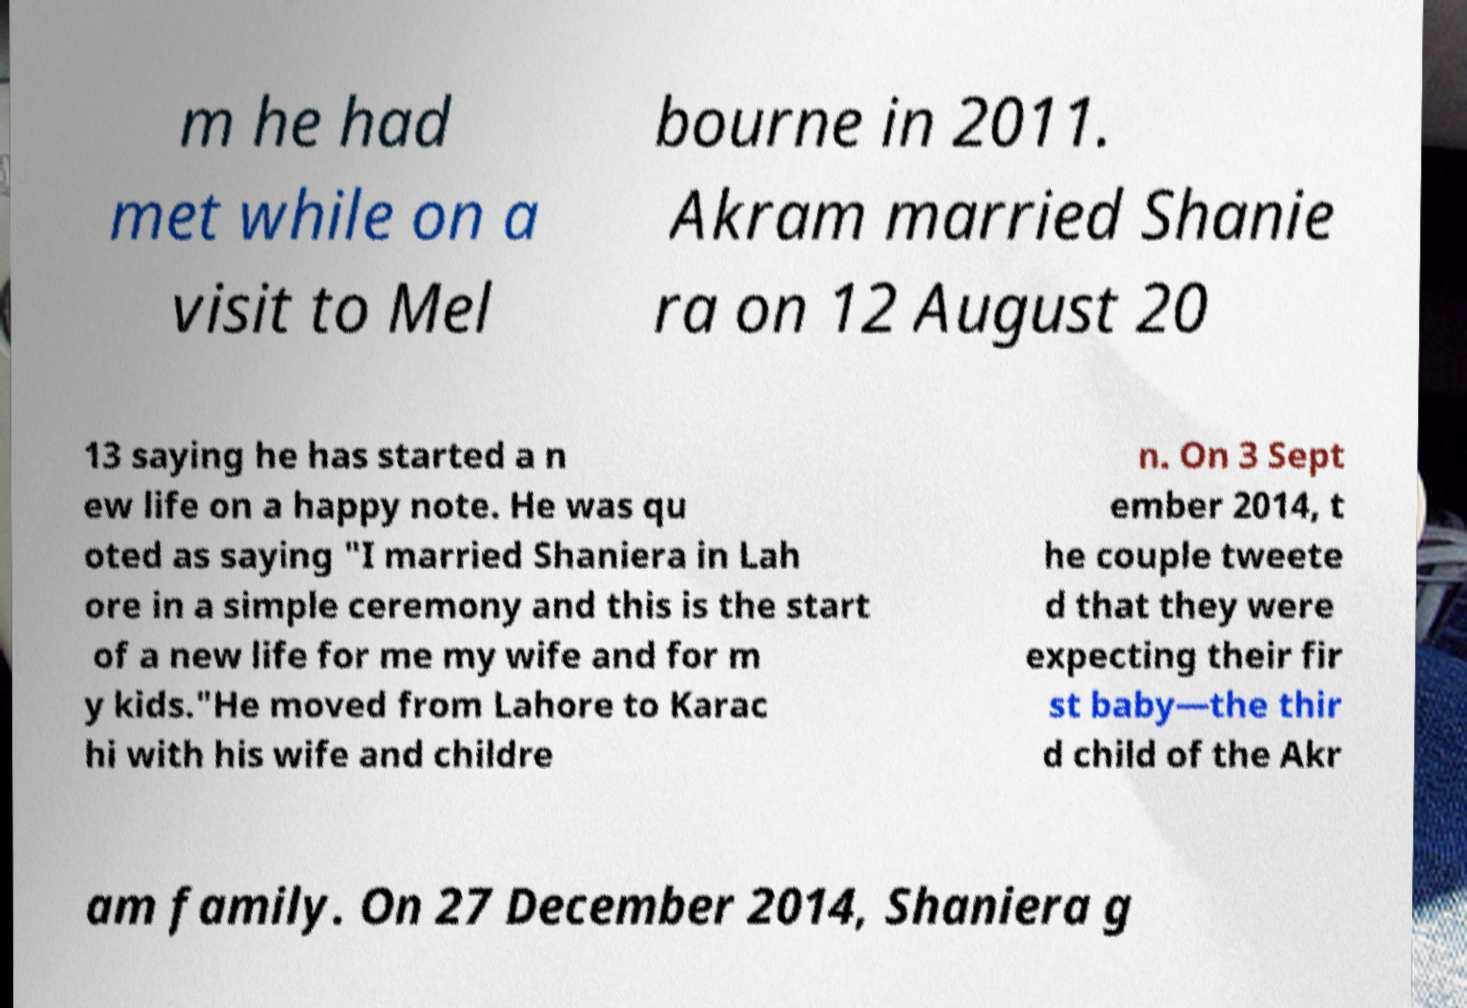Can you read and provide the text displayed in the image?This photo seems to have some interesting text. Can you extract and type it out for me? m he had met while on a visit to Mel bourne in 2011. Akram married Shanie ra on 12 August 20 13 saying he has started a n ew life on a happy note. He was qu oted as saying "I married Shaniera in Lah ore in a simple ceremony and this is the start of a new life for me my wife and for m y kids."He moved from Lahore to Karac hi with his wife and childre n. On 3 Sept ember 2014, t he couple tweete d that they were expecting their fir st baby—the thir d child of the Akr am family. On 27 December 2014, Shaniera g 